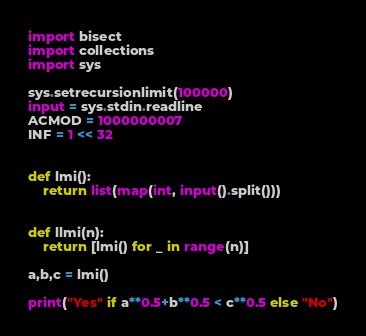<code> <loc_0><loc_0><loc_500><loc_500><_Python_>import bisect
import collections
import sys

sys.setrecursionlimit(100000)
input = sys.stdin.readline
ACMOD = 1000000007
INF = 1 << 32


def lmi():
    return list(map(int, input().split()))


def llmi(n):
    return [lmi() for _ in range(n)]

a,b,c = lmi()

print("Yes" if a**0.5+b**0.5 < c**0.5 else "No")</code> 